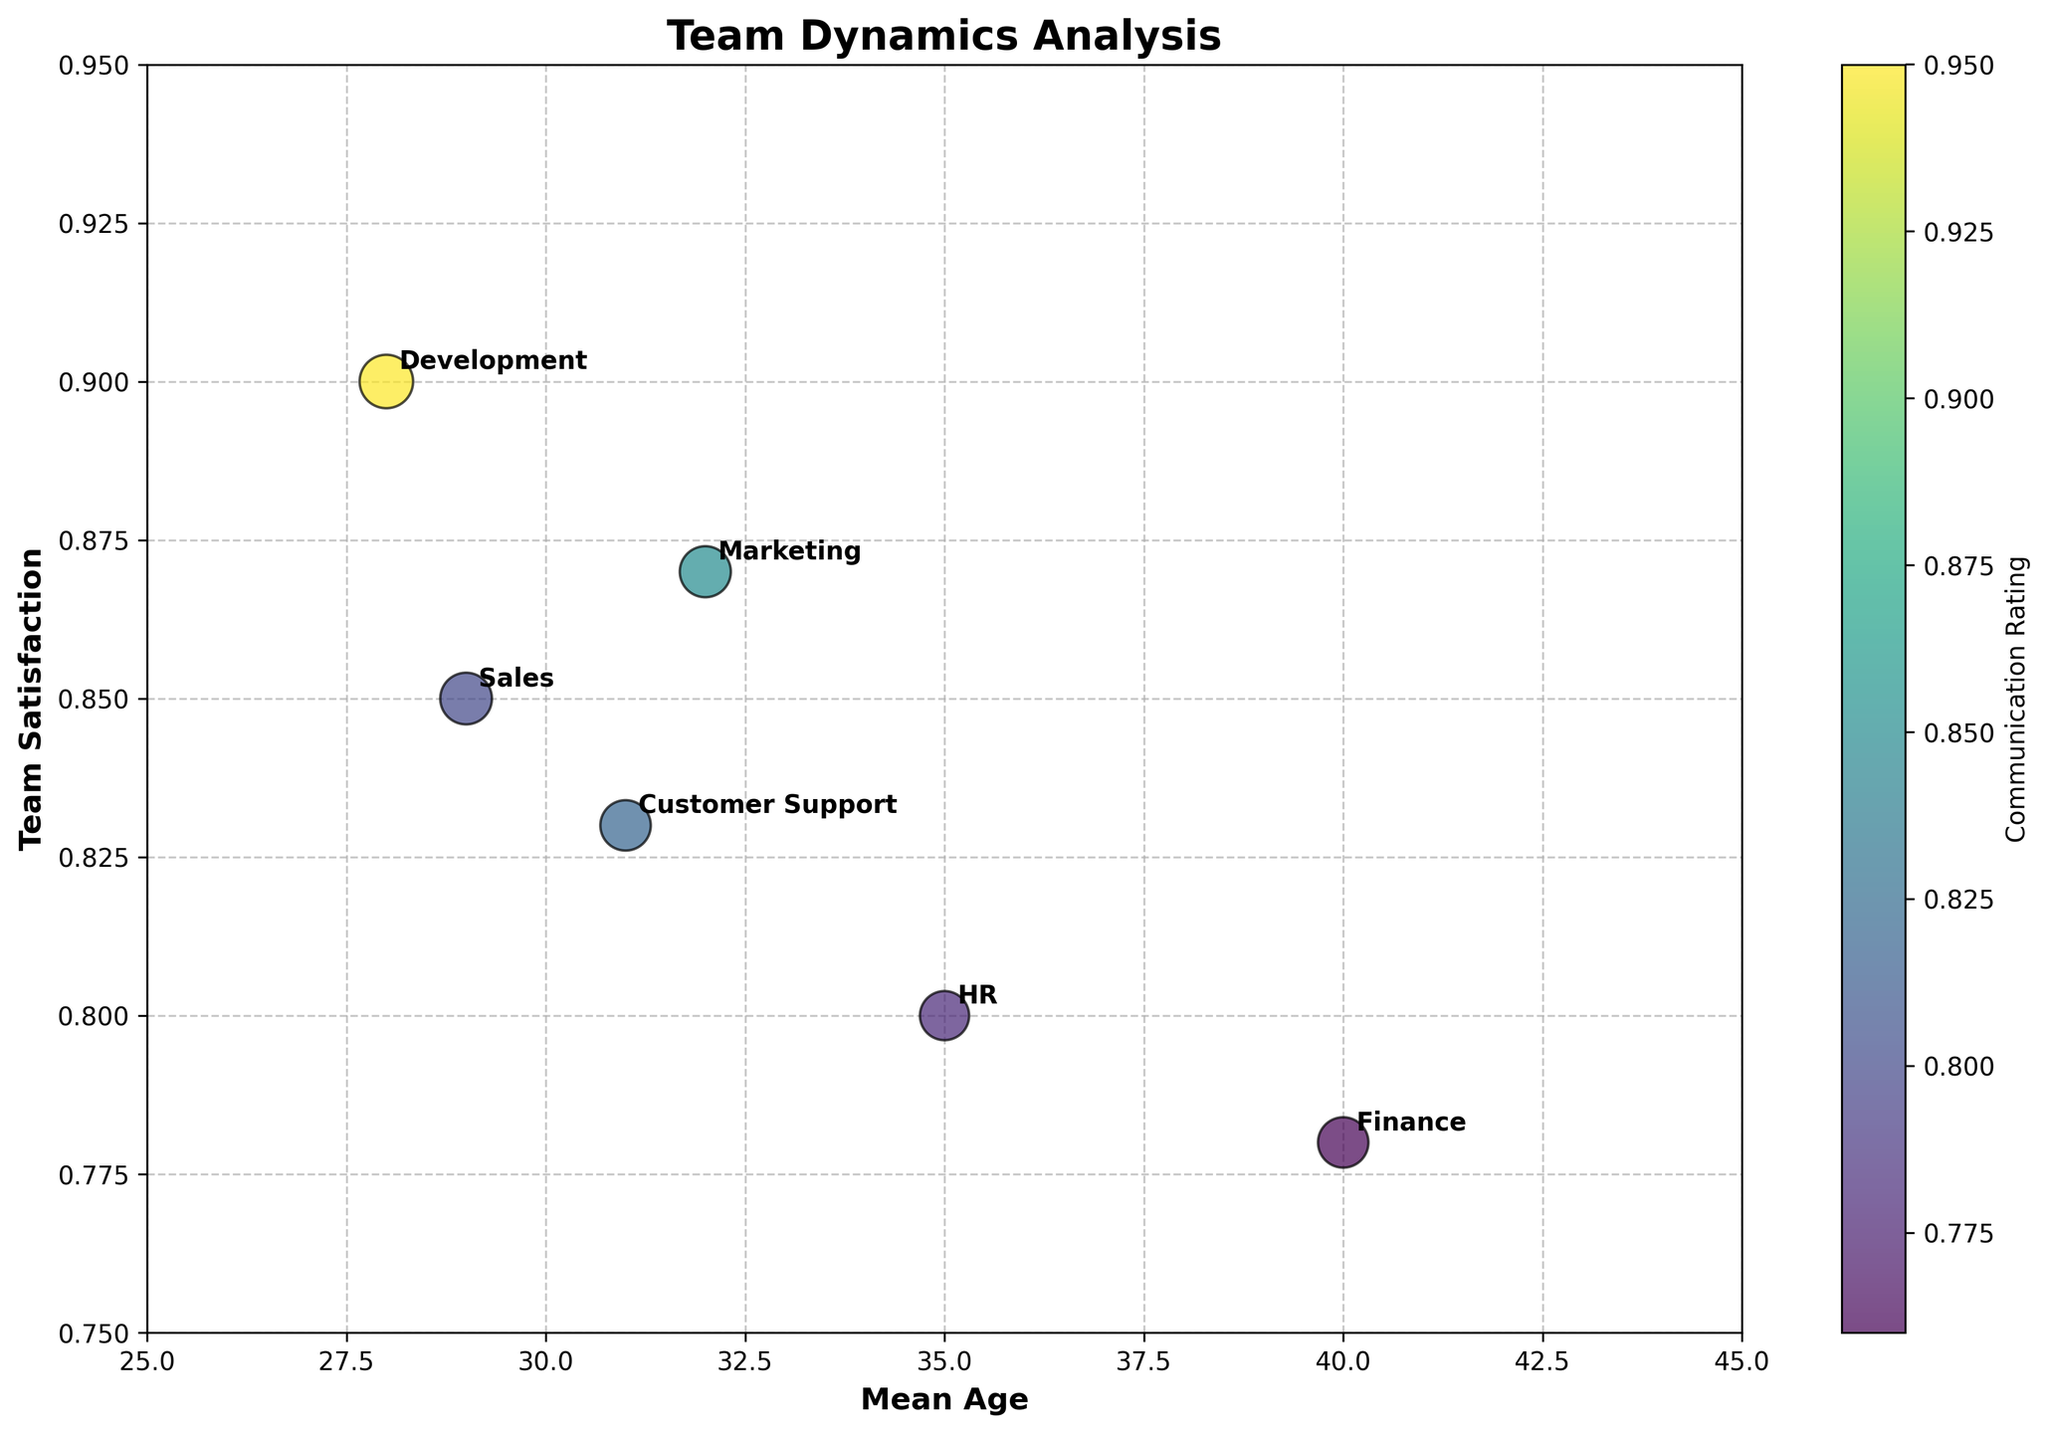What is the title of the figure? The title is displayed at the top of the chart.
Answer: Team Dynamics Analysis What is the x-axis label? Labels for axes are usually at the edge of the chart. The label for the x-axis is located at the bottom.
Answer: Mean Age What is the range of the y-axis? The y-axis range can be seen by looking at the lowest and highest values of the scale on the y-axis from left to right.
Answer: 0.75 to 0.95 Which team has the highest Team Satisfaction? Identify the highest data point on the y-axis and check the label associated with it.
Answer: Development Which team has the lowest Communication Rating? Color intensity or the color bar on the right shows the rating. Check the team corresponding to the least color intensity.
Answer: Finance On average, do teams with higher Experience Level have higher or lower Team Satisfaction? Compare the size of bubbles (representing Experience Level) with their vertical position (Team Satisfaction). Larger bubbles tend to be higher on y-axis.
Answer: Higher Which team has the smallest bubble size? Identify the smallest bubble visually. The size represents Experience Level, so find the smallest bubble.
Answer: HR How does Team Satisfaction change with Mean Age for teams on the chart? Notice the trend of bubble's vertical position as you move horizontally across the x-axis from left to right.
Answer: Generally increases Which team has the highest Communication Rating, and what is its Mean Age? Look for the team colored with highest intensity (based on color bar) and note their location on the x-axis.
Answer: Development, 28 How many teams have a Mean Age above 30? Count the number of bubbles positioned to the right of the vertical marker that represents age 30 on the x-axis.
Answer: 3 